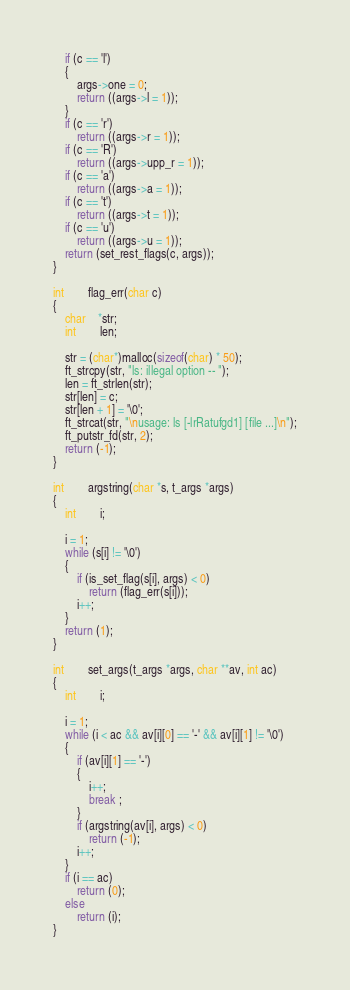Convert code to text. <code><loc_0><loc_0><loc_500><loc_500><_C_>	if (c == 'l')
	{
		args->one = 0;
		return ((args->l = 1));
	}
	if (c == 'r')
		return ((args->r = 1));
	if (c == 'R')
		return ((args->upp_r = 1));
	if (c == 'a')
		return ((args->a = 1));
	if (c == 't')
		return ((args->t = 1));
	if (c == 'u')
		return ((args->u = 1));
	return (set_rest_flags(c, args));
}

int		flag_err(char c)
{
	char	*str;
	int		len;

	str = (char*)malloc(sizeof(char) * 50);
	ft_strcpy(str, "ls: illegal option -- ");
	len = ft_strlen(str);
	str[len] = c;
	str[len + 1] = '\0';
	ft_strcat(str, "\nusage: ls [-lrRatufgd1] [file ...]\n");
	ft_putstr_fd(str, 2);
	return (-1);
}

int		argstring(char *s, t_args *args)
{
	int		i;

	i = 1;
	while (s[i] != '\0')
	{
		if (is_set_flag(s[i], args) < 0)
			return (flag_err(s[i]));
		i++;
	}
	return (1);
}

int		set_args(t_args *args, char **av, int ac)
{
	int		i;

	i = 1;
	while (i < ac && av[i][0] == '-' && av[i][1] != '\0')
	{
		if (av[i][1] == '-')
		{
			i++;
			break ;
		}
		if (argstring(av[i], args) < 0)
			return (-1);
		i++;
	}
	if (i == ac)
		return (0);
	else
		return (i);
}
</code> 